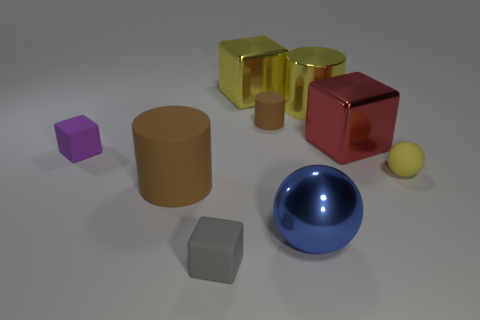Is the color of the matte ball the same as the metallic cylinder?
Keep it short and to the point. Yes. Does the blue thing have the same material as the tiny yellow ball?
Offer a terse response. No. What is the shape of the large rubber thing that is the same color as the tiny rubber cylinder?
Your answer should be very brief. Cylinder. What is the shape of the small rubber object to the left of the block in front of the tiny purple block?
Offer a terse response. Cube. Are there fewer blocks that are in front of the big rubber cylinder than large shiny cubes?
Give a very brief answer. Yes. What is the shape of the small purple rubber thing?
Make the answer very short. Cube. There is a metallic thing that is left of the large blue sphere; how big is it?
Make the answer very short. Large. The cylinder that is the same size as the gray object is what color?
Offer a very short reply. Brown. Is there a small thing of the same color as the large metallic cylinder?
Offer a very short reply. Yes. Are there fewer tiny things that are behind the tiny brown matte object than large objects left of the blue object?
Provide a succinct answer. Yes. 